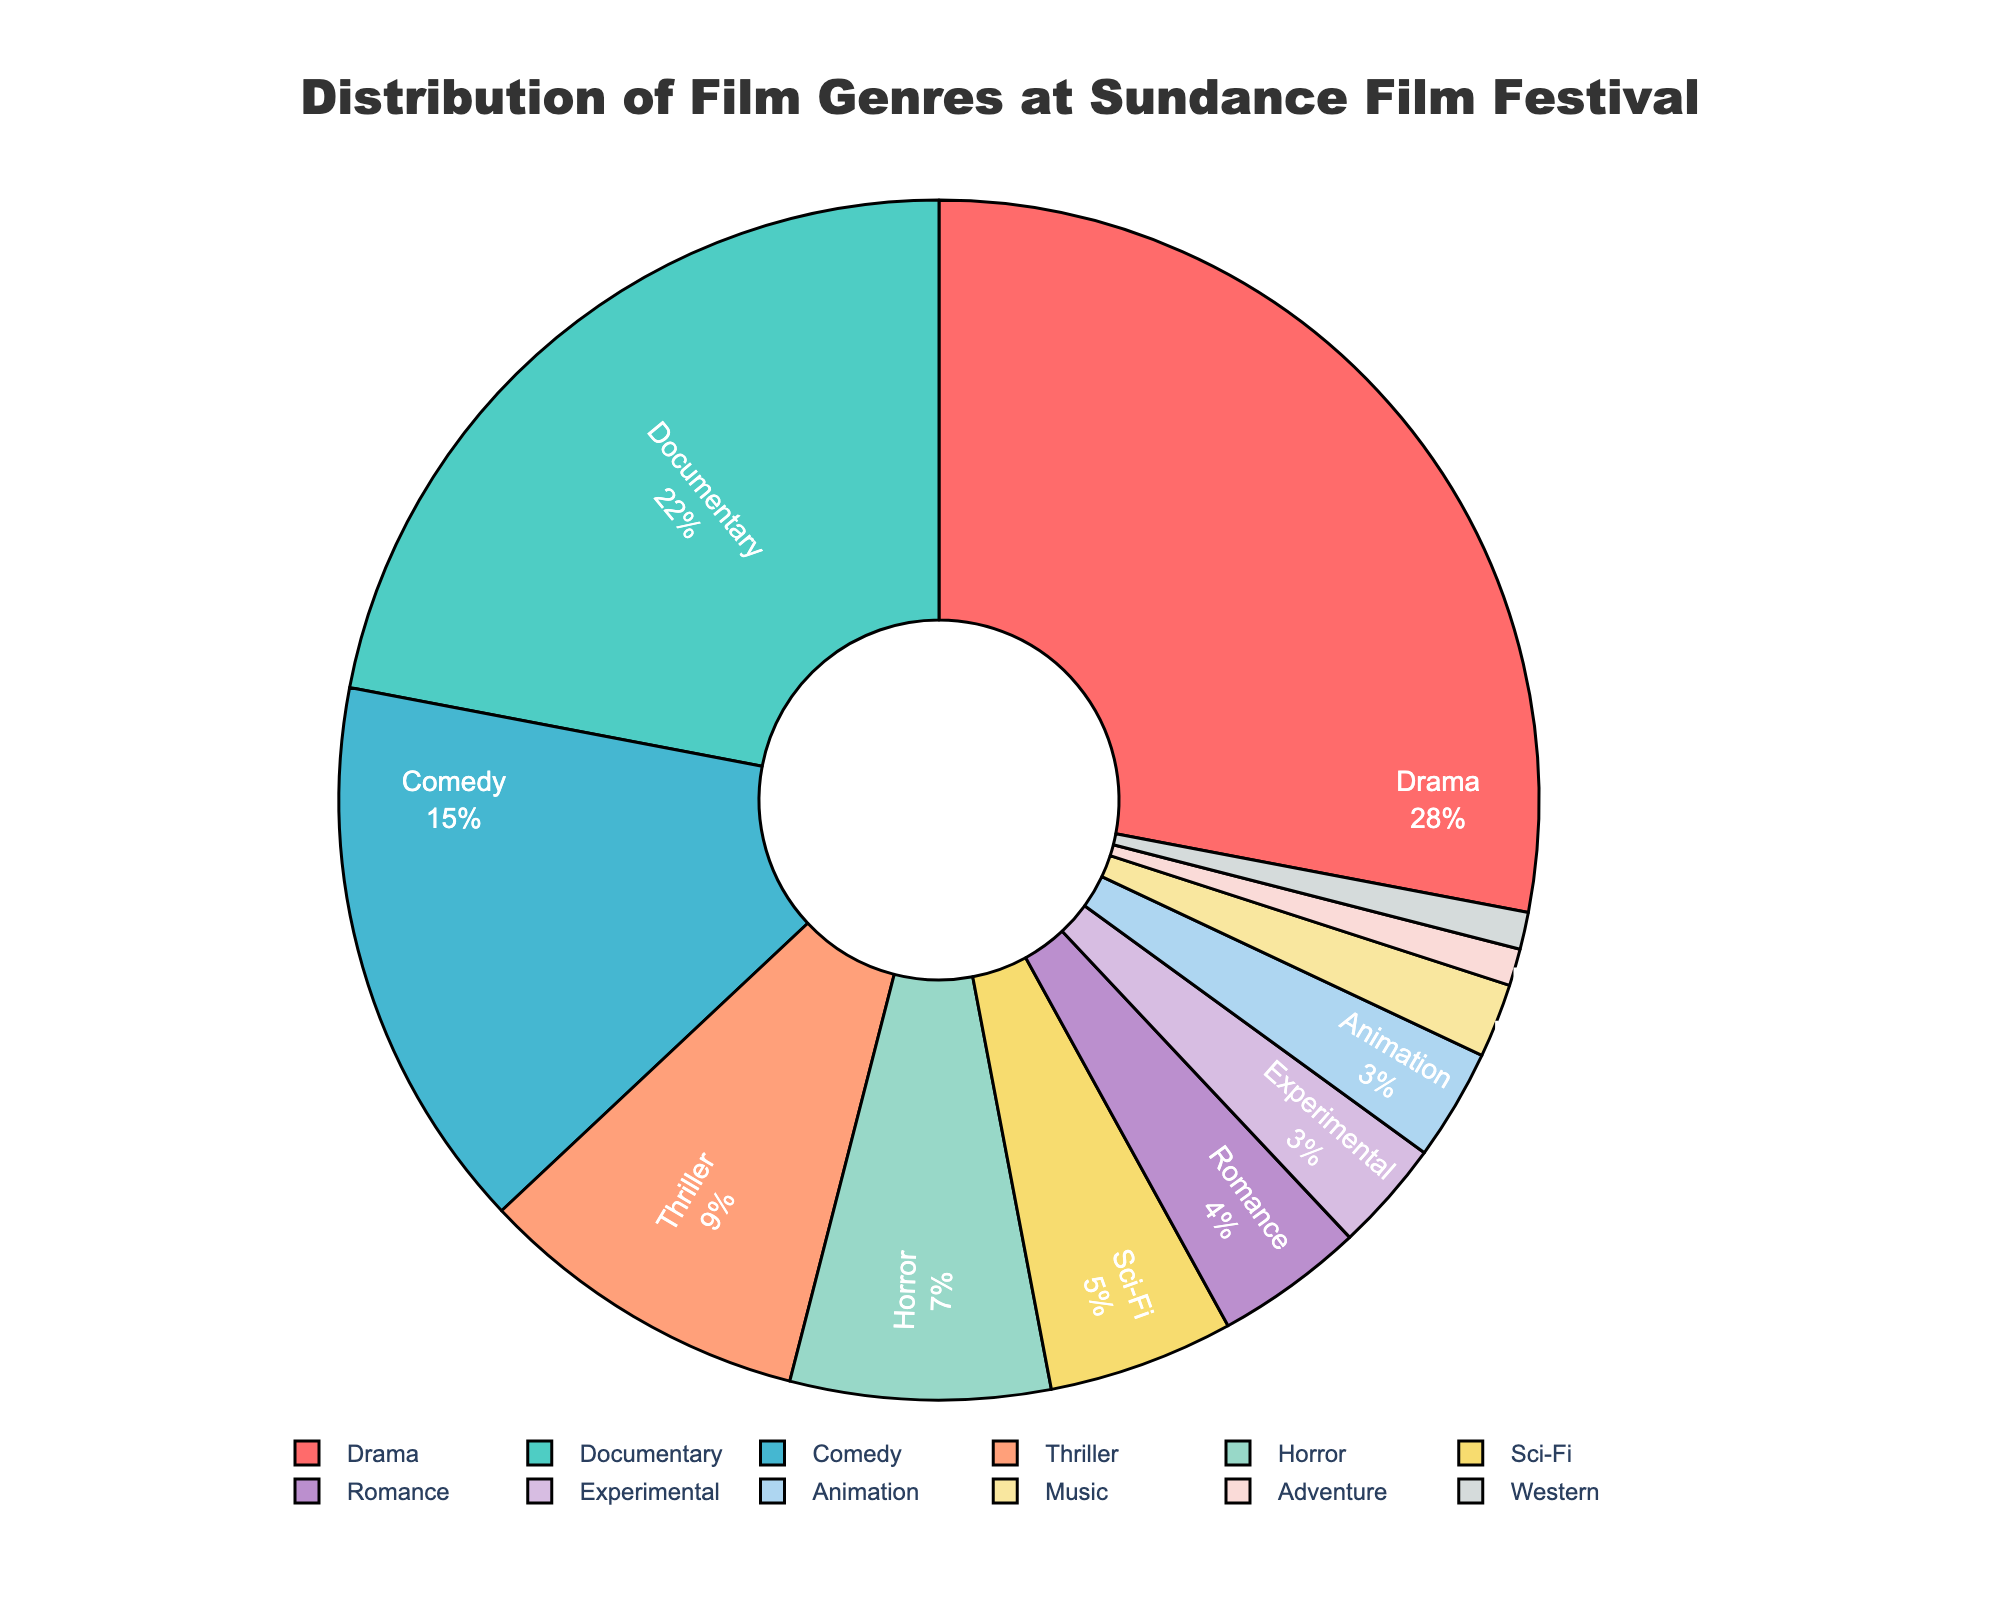What's the most common film genre at Sundance Film Festival? By looking at the pie chart, find the genre with the largest percentage.
Answer: Drama How much more prevalent is Drama compared to Horror? Subtract the percentage of Horror from the percentage of Drama (28% - 7%).
Answer: 21% What's the combined percentage of Documentary and Comedy films? Add the percentages of Documentary and Comedy (22% + 15%).
Answer: 37% Which genre has a higher percentage: Thriller or Sci-Fi? Compare the percentages of Thriller and Sci-Fi. Thriller has 9% and Sci-Fi has 5%, so Thriller is higher.
Answer: Thriller What percentage of films are Romance and Animation combined? Add the percentages of Romance and Animation (4% + 3%).
Answer: 7% Which genres have the same percentage representation in the festival? Identify genres with equal percentages by looking at the pie chart. Experimental and Animation both have 3%, and Adventure and Western both have 1%.
Answer: Experimental and Animation; Adventure and Western How does the presence of Music films compare to Adventure films? Compare the percentages of Music and Adventure. Music has 2% and Adventure has 1%, so Music is twice Adventure.
Answer: Music has double the percentage What is the percentage representation difference between the highest (Drama) and lowest (Western) genres? Subtract the percentage of Western (1%) from Drama (28%).
Answer: 27% Which genre has approximately half the representation of Comedy? Find the genre with a percentage closest to half of Comedy (15%), which is close to 7.5%. Horror at 7% is the closest.
Answer: Horror If you combine the percentage of Sci-Fi and Romance, does it exceed that of Thriller? Add the percentages of Sci-Fi and Romance (5% + 4% = 9%) and compare with Thriller (9%). They are equal.
Answer: No, they are equal 